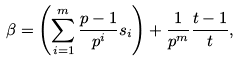Convert formula to latex. <formula><loc_0><loc_0><loc_500><loc_500>\beta = \left ( \sum _ { i = 1 } ^ { m } \frac { p - 1 } { p ^ { i } } s _ { i } \right ) + \frac { 1 } { p ^ { m } } \frac { t - 1 } { t } ,</formula> 